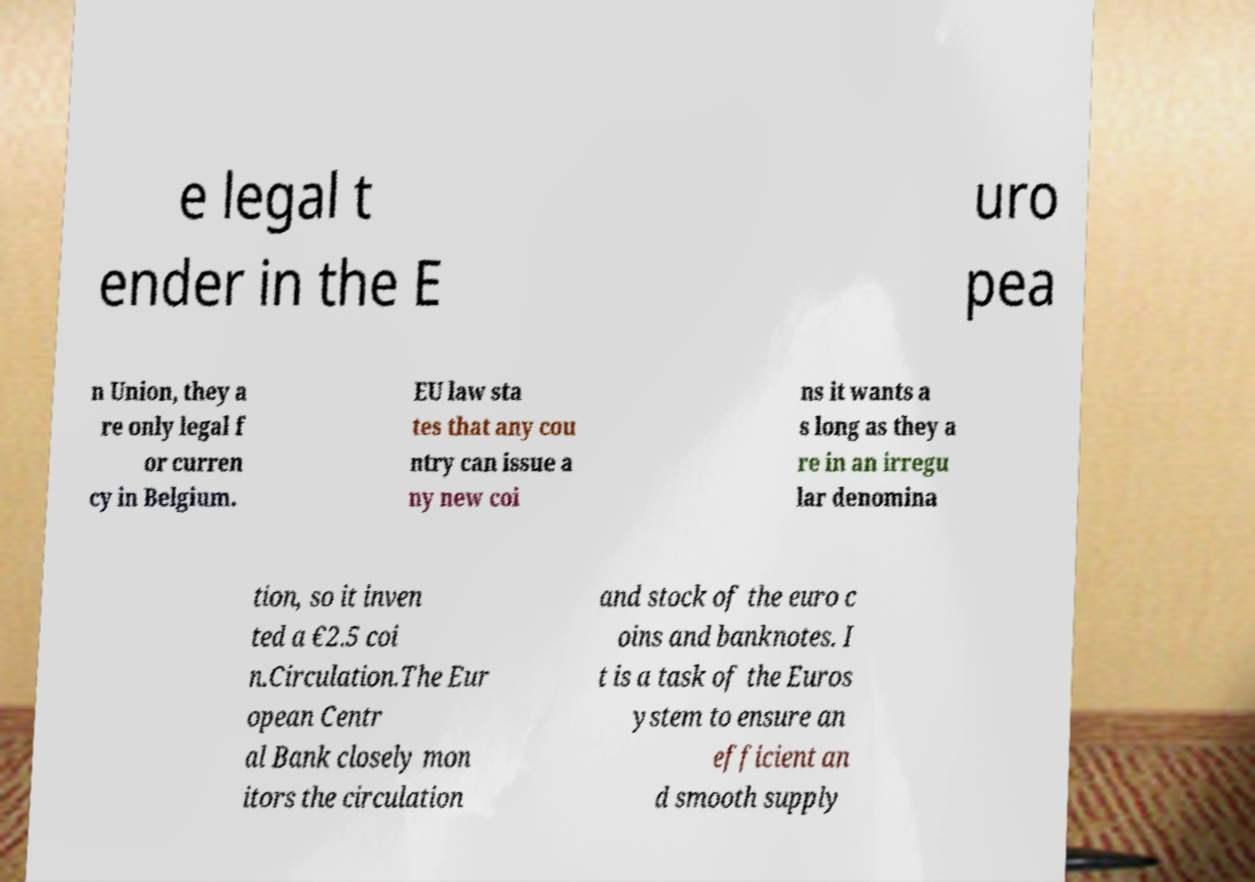There's text embedded in this image that I need extracted. Can you transcribe it verbatim? e legal t ender in the E uro pea n Union, they a re only legal f or curren cy in Belgium. EU law sta tes that any cou ntry can issue a ny new coi ns it wants a s long as they a re in an irregu lar denomina tion, so it inven ted a €2.5 coi n.Circulation.The Eur opean Centr al Bank closely mon itors the circulation and stock of the euro c oins and banknotes. I t is a task of the Euros ystem to ensure an efficient an d smooth supply 